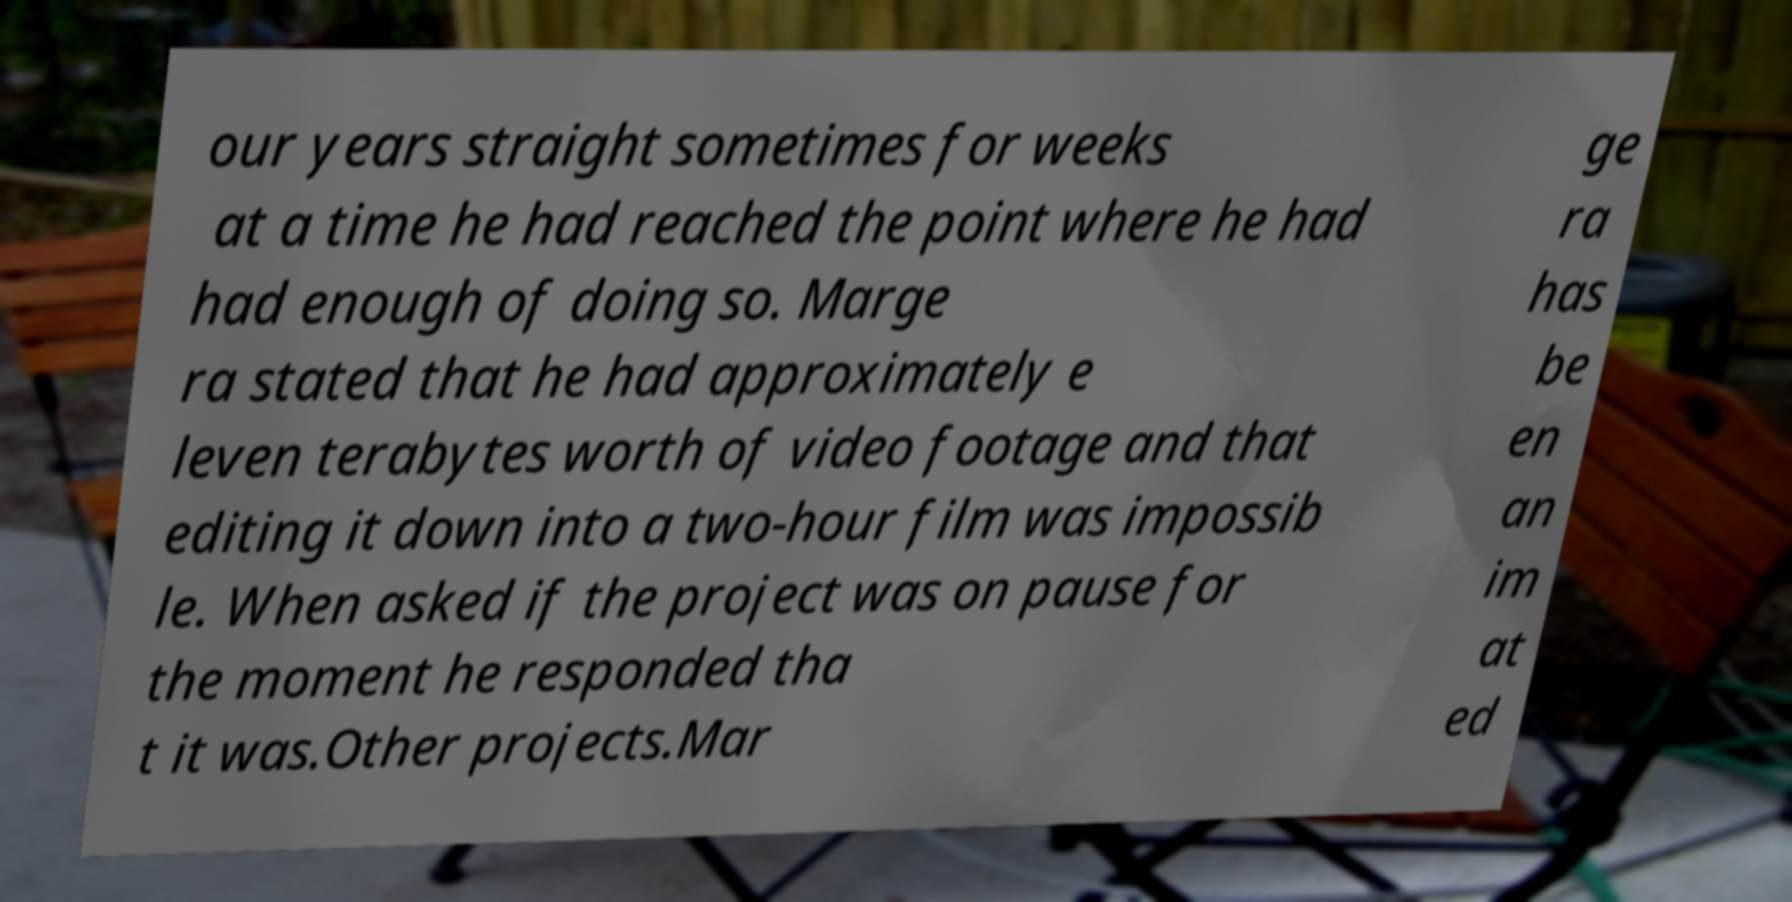There's text embedded in this image that I need extracted. Can you transcribe it verbatim? our years straight sometimes for weeks at a time he had reached the point where he had had enough of doing so. Marge ra stated that he had approximately e leven terabytes worth of video footage and that editing it down into a two-hour film was impossib le. When asked if the project was on pause for the moment he responded tha t it was.Other projects.Mar ge ra has be en an im at ed 